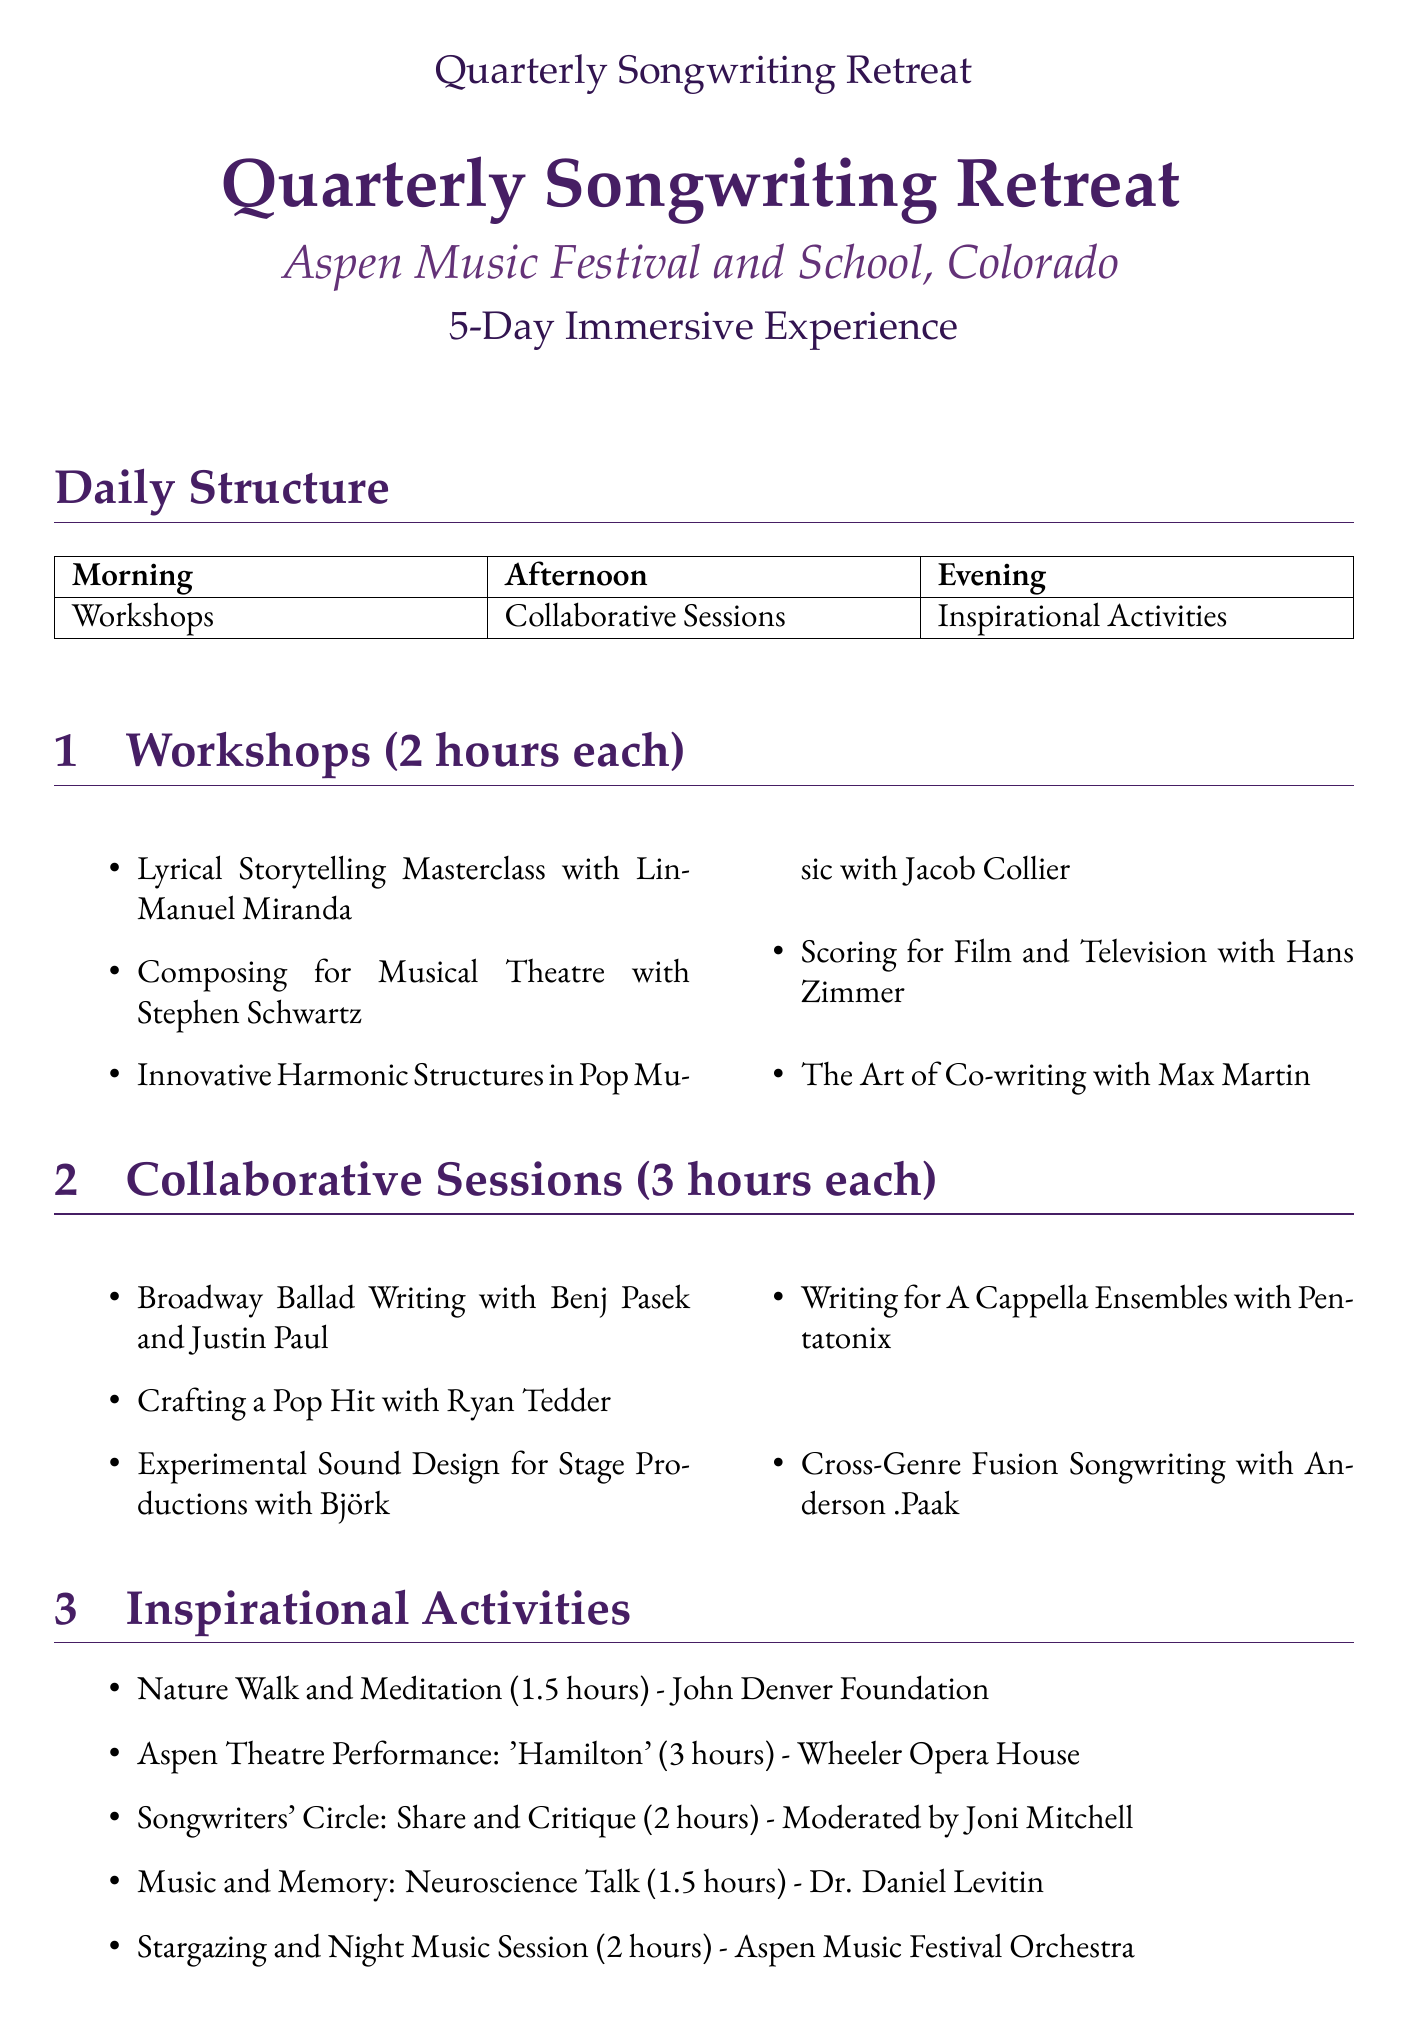What is the total duration of the retreat? The total duration is mentioned in the retreat details at the beginning of the document as 5 days.
Answer: 5 days Who is the instructor for the "Lyrical Storytelling Masterclass"? The document lists instructors for each workshop, and Lin-Manuel Miranda is the instructor for this masterclass.
Answer: Lin-Manuel Miranda What is the duration of each workshop? The durations for workshops are specified in the document, indicating that each workshop lasts 2 hours.
Answer: 2 hours Which facilitator leads the "Cross-Genre Fusion Songwriting" session? The facilitator for this session is listed as Anderson .Paak in the collaborative sessions section.
Answer: Anderson .Paak How long is the "Aspen Theatre Performance: 'Hamilton'"? The duration of this performance is provided in the inspirational activities section, where it mentions a duration of 3 hours.
Answer: 3 hours What is the title of the mid-retreat concert? The mid-retreat concert title is "Mid-Retreat Concert: Collaborative Performances" as described in the special events section.
Answer: Mid-Retreat Concert: Collaborative Performances Who moderates the "Songwriters' Circle: Share and Critique"? The document indicates that Joni Mitchell is the moderator for this activity.
Answer: Joni Mitchell How many networking opportunities are listed? The document presents three different networking opportunities, which can be counted in that section.
Answer: 3 